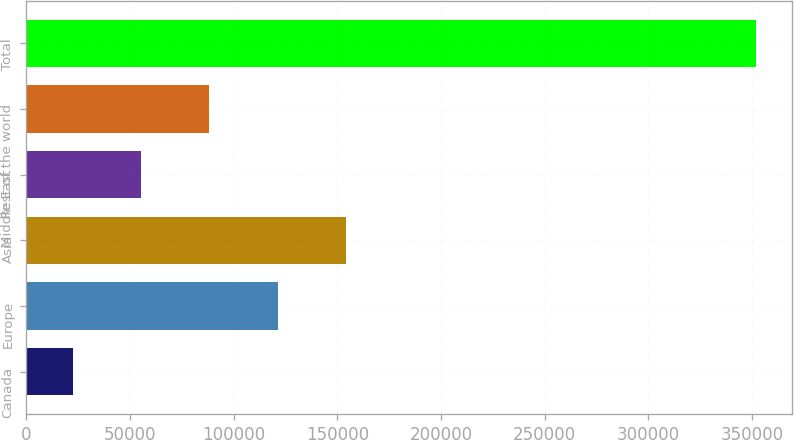<chart> <loc_0><loc_0><loc_500><loc_500><bar_chart><fcel>Canada<fcel>Europe<fcel>Asia<fcel>Middle East<fcel>Rest of the world<fcel>Total<nl><fcel>22360<fcel>121208<fcel>154158<fcel>55309.4<fcel>88258.8<fcel>351854<nl></chart> 